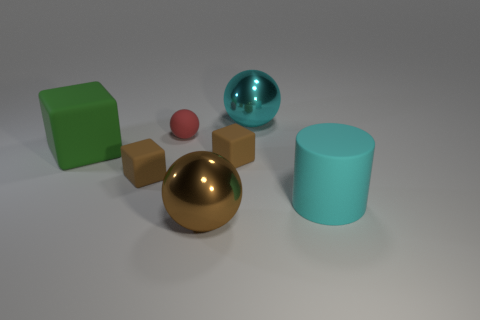Add 2 big brown objects. How many objects exist? 9 Subtract all spheres. How many objects are left? 4 Subtract all objects. Subtract all tiny metal cylinders. How many objects are left? 0 Add 1 big cyan shiny objects. How many big cyan shiny objects are left? 2 Add 6 metal things. How many metal things exist? 8 Subtract 0 yellow balls. How many objects are left? 7 